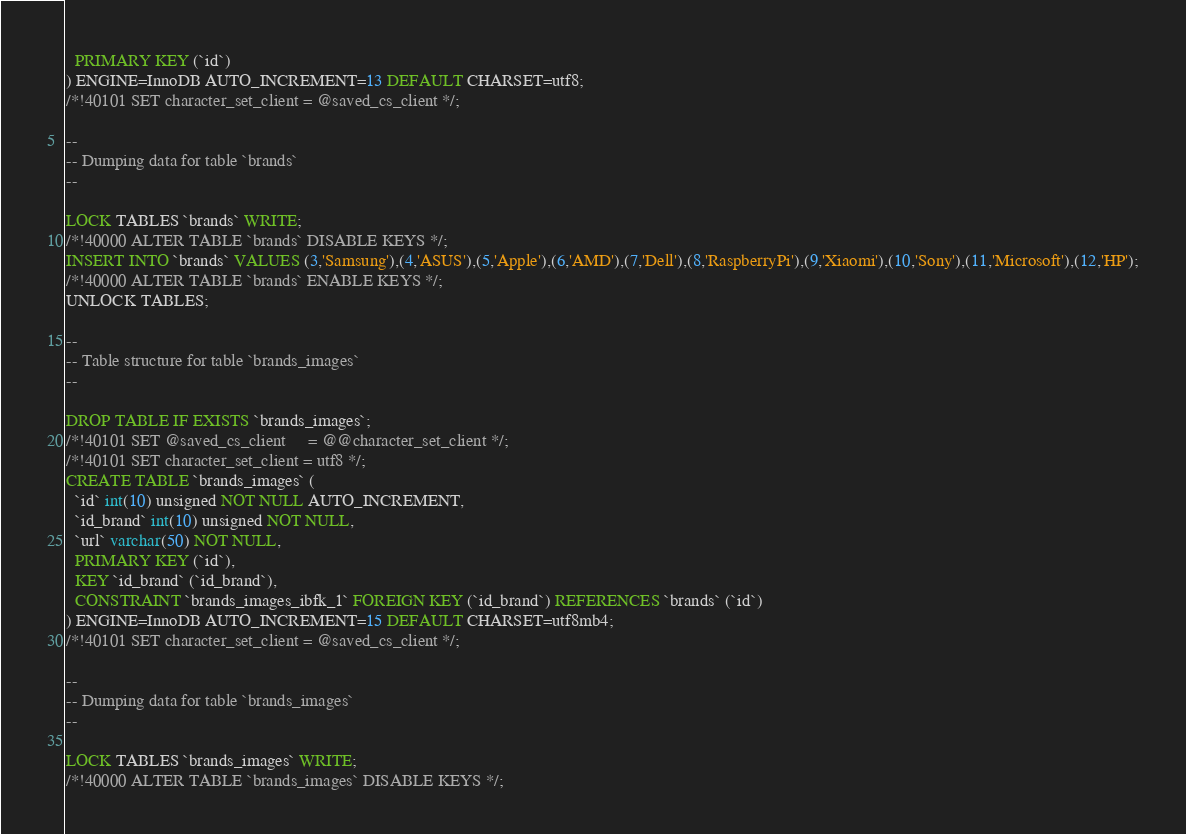Convert code to text. <code><loc_0><loc_0><loc_500><loc_500><_SQL_>  PRIMARY KEY (`id`)
) ENGINE=InnoDB AUTO_INCREMENT=13 DEFAULT CHARSET=utf8;
/*!40101 SET character_set_client = @saved_cs_client */;

--
-- Dumping data for table `brands`
--

LOCK TABLES `brands` WRITE;
/*!40000 ALTER TABLE `brands` DISABLE KEYS */;
INSERT INTO `brands` VALUES (3,'Samsung'),(4,'ASUS'),(5,'Apple'),(6,'AMD'),(7,'Dell'),(8,'RaspberryPi'),(9,'Xiaomi'),(10,'Sony'),(11,'Microsoft'),(12,'HP');
/*!40000 ALTER TABLE `brands` ENABLE KEYS */;
UNLOCK TABLES;

--
-- Table structure for table `brands_images`
--

DROP TABLE IF EXISTS `brands_images`;
/*!40101 SET @saved_cs_client     = @@character_set_client */;
/*!40101 SET character_set_client = utf8 */;
CREATE TABLE `brands_images` (
  `id` int(10) unsigned NOT NULL AUTO_INCREMENT,
  `id_brand` int(10) unsigned NOT NULL,
  `url` varchar(50) NOT NULL,
  PRIMARY KEY (`id`),
  KEY `id_brand` (`id_brand`),
  CONSTRAINT `brands_images_ibfk_1` FOREIGN KEY (`id_brand`) REFERENCES `brands` (`id`)
) ENGINE=InnoDB AUTO_INCREMENT=15 DEFAULT CHARSET=utf8mb4;
/*!40101 SET character_set_client = @saved_cs_client */;

--
-- Dumping data for table `brands_images`
--

LOCK TABLES `brands_images` WRITE;
/*!40000 ALTER TABLE `brands_images` DISABLE KEYS */;</code> 